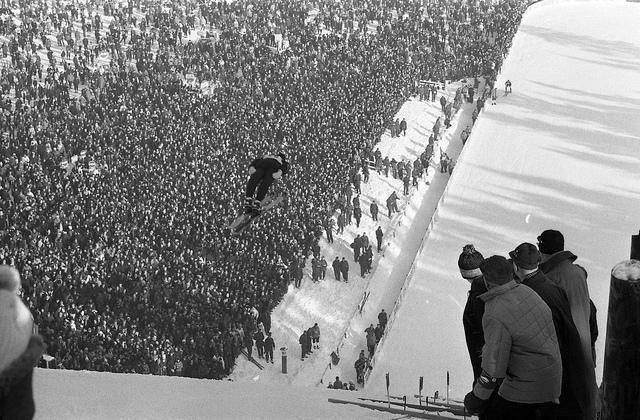How many people are visible?
Give a very brief answer. 5. How many carrots are on top of the cartoon image?
Give a very brief answer. 0. 